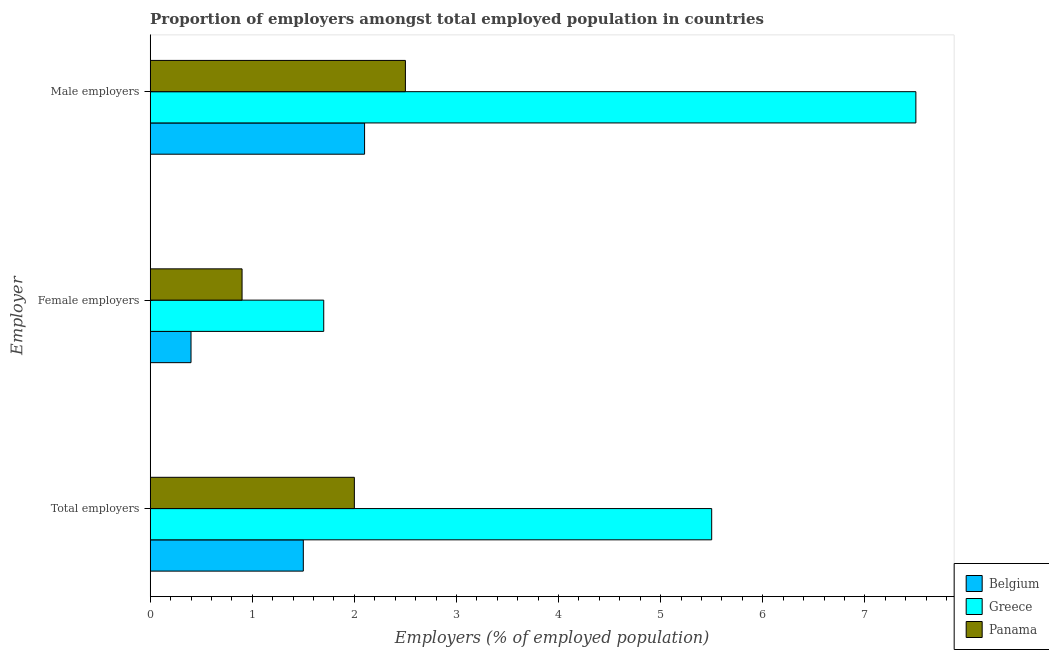Are the number of bars per tick equal to the number of legend labels?
Give a very brief answer. Yes. Are the number of bars on each tick of the Y-axis equal?
Keep it short and to the point. Yes. What is the label of the 2nd group of bars from the top?
Keep it short and to the point. Female employers. Across all countries, what is the maximum percentage of male employers?
Keep it short and to the point. 7.5. Across all countries, what is the minimum percentage of total employers?
Provide a short and direct response. 1.5. In which country was the percentage of total employers maximum?
Your response must be concise. Greece. What is the total percentage of female employers in the graph?
Provide a short and direct response. 3. What is the difference between the percentage of total employers in Belgium and the percentage of male employers in Panama?
Your answer should be very brief. -1. What is the average percentage of male employers per country?
Your answer should be very brief. 4.03. What is the difference between the percentage of male employers and percentage of female employers in Greece?
Your answer should be compact. 5.8. In how many countries, is the percentage of total employers greater than 7.2 %?
Give a very brief answer. 0. What is the ratio of the percentage of male employers in Greece to that in Belgium?
Keep it short and to the point. 3.57. Is the percentage of female employers in Panama less than that in Greece?
Offer a terse response. Yes. What is the difference between the highest and the second highest percentage of female employers?
Ensure brevity in your answer.  0.8. What is the difference between the highest and the lowest percentage of male employers?
Ensure brevity in your answer.  5.4. In how many countries, is the percentage of female employers greater than the average percentage of female employers taken over all countries?
Provide a succinct answer. 1. What does the 1st bar from the bottom in Male employers represents?
Your answer should be very brief. Belgium. Are all the bars in the graph horizontal?
Offer a terse response. Yes. Are the values on the major ticks of X-axis written in scientific E-notation?
Ensure brevity in your answer.  No. How many legend labels are there?
Provide a succinct answer. 3. How are the legend labels stacked?
Your answer should be very brief. Vertical. What is the title of the graph?
Make the answer very short. Proportion of employers amongst total employed population in countries. Does "Syrian Arab Republic" appear as one of the legend labels in the graph?
Give a very brief answer. No. What is the label or title of the X-axis?
Offer a very short reply. Employers (% of employed population). What is the label or title of the Y-axis?
Your answer should be very brief. Employer. What is the Employers (% of employed population) of Belgium in Female employers?
Offer a very short reply. 0.4. What is the Employers (% of employed population) in Greece in Female employers?
Your answer should be very brief. 1.7. What is the Employers (% of employed population) in Panama in Female employers?
Your response must be concise. 0.9. What is the Employers (% of employed population) in Belgium in Male employers?
Ensure brevity in your answer.  2.1. What is the Employers (% of employed population) of Greece in Male employers?
Make the answer very short. 7.5. What is the Employers (% of employed population) in Panama in Male employers?
Offer a terse response. 2.5. Across all Employer, what is the maximum Employers (% of employed population) of Belgium?
Make the answer very short. 2.1. Across all Employer, what is the maximum Employers (% of employed population) of Greece?
Ensure brevity in your answer.  7.5. Across all Employer, what is the maximum Employers (% of employed population) of Panama?
Ensure brevity in your answer.  2.5. Across all Employer, what is the minimum Employers (% of employed population) of Belgium?
Your answer should be compact. 0.4. Across all Employer, what is the minimum Employers (% of employed population) in Greece?
Ensure brevity in your answer.  1.7. Across all Employer, what is the minimum Employers (% of employed population) of Panama?
Your answer should be compact. 0.9. What is the total Employers (% of employed population) of Greece in the graph?
Your answer should be compact. 14.7. What is the total Employers (% of employed population) of Panama in the graph?
Ensure brevity in your answer.  5.4. What is the difference between the Employers (% of employed population) in Belgium in Total employers and that in Female employers?
Offer a terse response. 1.1. What is the difference between the Employers (% of employed population) in Greece in Total employers and that in Female employers?
Provide a short and direct response. 3.8. What is the difference between the Employers (% of employed population) of Panama in Total employers and that in Male employers?
Ensure brevity in your answer.  -0.5. What is the difference between the Employers (% of employed population) of Greece in Female employers and that in Male employers?
Keep it short and to the point. -5.8. What is the difference between the Employers (% of employed population) of Panama in Female employers and that in Male employers?
Your response must be concise. -1.6. What is the difference between the Employers (% of employed population) in Belgium in Total employers and the Employers (% of employed population) in Greece in Female employers?
Offer a terse response. -0.2. What is the difference between the Employers (% of employed population) in Belgium in Total employers and the Employers (% of employed population) in Panama in Female employers?
Offer a terse response. 0.6. What is the difference between the Employers (% of employed population) of Greece in Total employers and the Employers (% of employed population) of Panama in Female employers?
Provide a short and direct response. 4.6. What is the difference between the Employers (% of employed population) of Belgium in Total employers and the Employers (% of employed population) of Greece in Male employers?
Give a very brief answer. -6. What is the difference between the Employers (% of employed population) of Greece in Total employers and the Employers (% of employed population) of Panama in Male employers?
Your response must be concise. 3. What is the difference between the Employers (% of employed population) in Greece in Female employers and the Employers (% of employed population) in Panama in Male employers?
Provide a short and direct response. -0.8. What is the average Employers (% of employed population) of Panama per Employer?
Your response must be concise. 1.8. What is the difference between the Employers (% of employed population) in Belgium and Employers (% of employed population) in Panama in Total employers?
Your answer should be very brief. -0.5. What is the difference between the Employers (% of employed population) in Belgium and Employers (% of employed population) in Panama in Female employers?
Provide a succinct answer. -0.5. What is the difference between the Employers (% of employed population) of Greece and Employers (% of employed population) of Panama in Female employers?
Your answer should be compact. 0.8. What is the difference between the Employers (% of employed population) in Greece and Employers (% of employed population) in Panama in Male employers?
Your answer should be very brief. 5. What is the ratio of the Employers (% of employed population) of Belgium in Total employers to that in Female employers?
Offer a very short reply. 3.75. What is the ratio of the Employers (% of employed population) in Greece in Total employers to that in Female employers?
Your response must be concise. 3.24. What is the ratio of the Employers (% of employed population) of Panama in Total employers to that in Female employers?
Ensure brevity in your answer.  2.22. What is the ratio of the Employers (% of employed population) of Greece in Total employers to that in Male employers?
Offer a terse response. 0.73. What is the ratio of the Employers (% of employed population) in Panama in Total employers to that in Male employers?
Provide a succinct answer. 0.8. What is the ratio of the Employers (% of employed population) in Belgium in Female employers to that in Male employers?
Offer a terse response. 0.19. What is the ratio of the Employers (% of employed population) in Greece in Female employers to that in Male employers?
Give a very brief answer. 0.23. What is the ratio of the Employers (% of employed population) of Panama in Female employers to that in Male employers?
Provide a short and direct response. 0.36. What is the difference between the highest and the second highest Employers (% of employed population) of Belgium?
Offer a very short reply. 0.6. What is the difference between the highest and the second highest Employers (% of employed population) of Greece?
Provide a short and direct response. 2. What is the difference between the highest and the second highest Employers (% of employed population) in Panama?
Ensure brevity in your answer.  0.5. What is the difference between the highest and the lowest Employers (% of employed population) of Belgium?
Your answer should be very brief. 1.7. What is the difference between the highest and the lowest Employers (% of employed population) in Greece?
Offer a very short reply. 5.8. What is the difference between the highest and the lowest Employers (% of employed population) in Panama?
Offer a terse response. 1.6. 